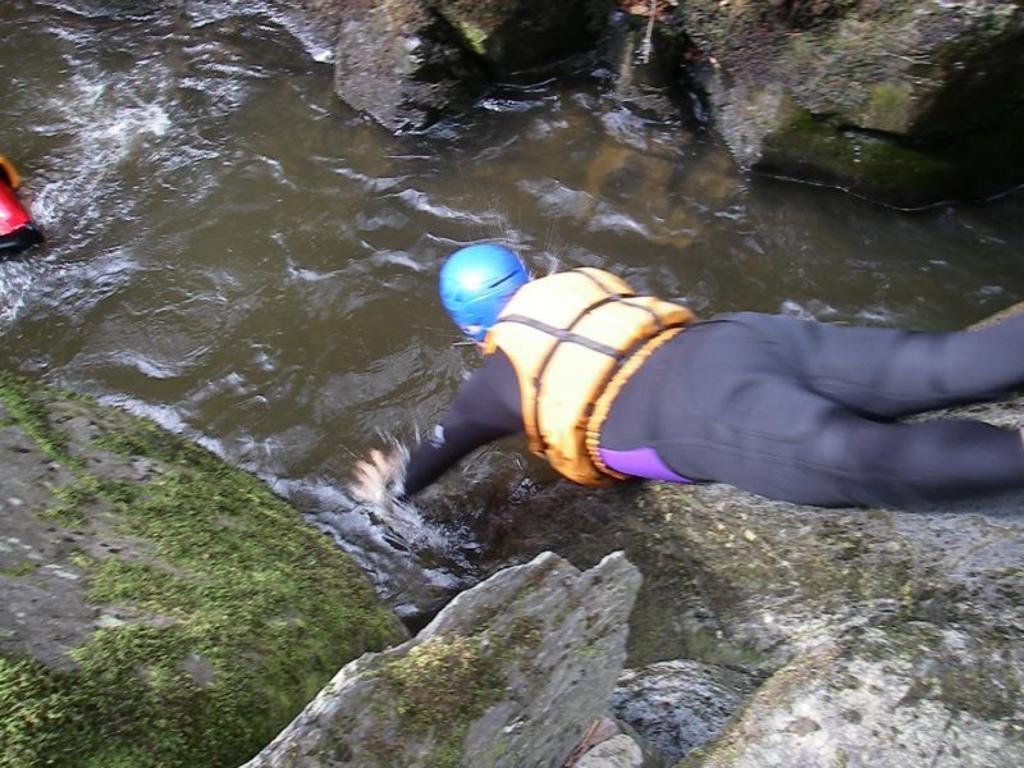Please provide a concise description of this image. The man is highlighted in this picture, as we can he is jumping into a water. A man wore jacket and helmet. This are freshwater river. Around this water there are stones. The grass is on the stone. This is a floating water river, as we can see there are waves. 